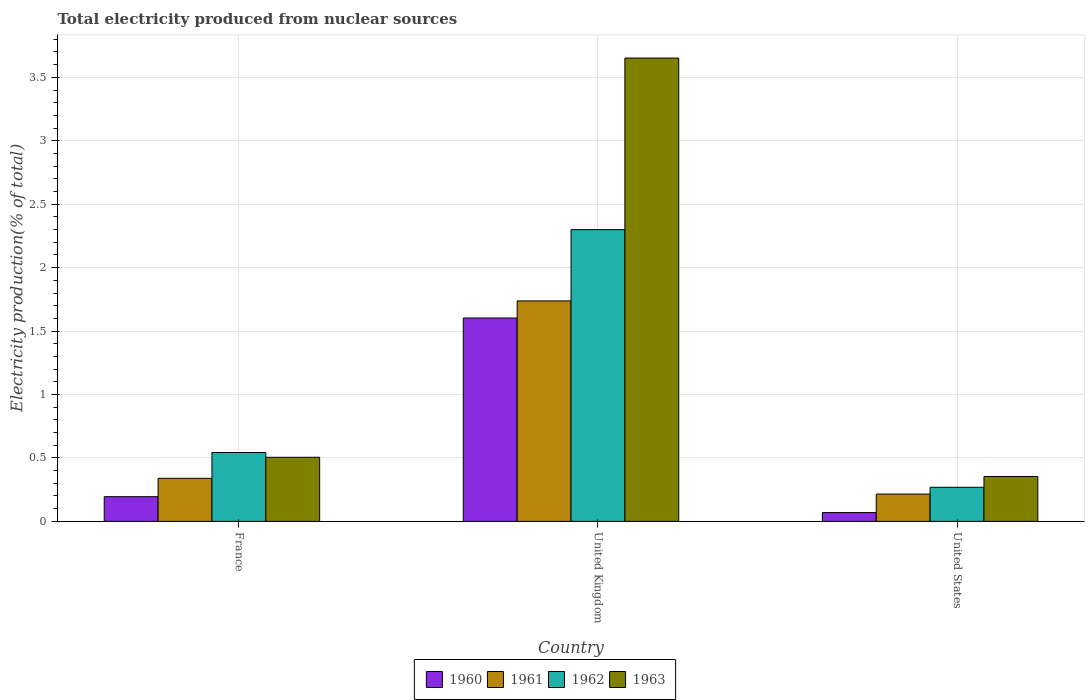Are the number of bars per tick equal to the number of legend labels?
Ensure brevity in your answer.  Yes. Are the number of bars on each tick of the X-axis equal?
Your answer should be very brief. Yes. How many bars are there on the 3rd tick from the left?
Your answer should be very brief. 4. What is the label of the 2nd group of bars from the left?
Ensure brevity in your answer.  United Kingdom. What is the total electricity produced in 1962 in United Kingdom?
Provide a succinct answer. 2.3. Across all countries, what is the maximum total electricity produced in 1962?
Offer a very short reply. 2.3. Across all countries, what is the minimum total electricity produced in 1963?
Give a very brief answer. 0.35. In which country was the total electricity produced in 1963 minimum?
Offer a very short reply. United States. What is the total total electricity produced in 1960 in the graph?
Ensure brevity in your answer.  1.87. What is the difference between the total electricity produced in 1961 in France and that in United States?
Keep it short and to the point. 0.12. What is the difference between the total electricity produced in 1962 in France and the total electricity produced in 1961 in United States?
Keep it short and to the point. 0.33. What is the average total electricity produced in 1962 per country?
Your answer should be very brief. 1.04. What is the difference between the total electricity produced of/in 1961 and total electricity produced of/in 1962 in United Kingdom?
Provide a succinct answer. -0.56. In how many countries, is the total electricity produced in 1960 greater than 3.7 %?
Provide a succinct answer. 0. What is the ratio of the total electricity produced in 1962 in France to that in United States?
Provide a succinct answer. 2.02. Is the total electricity produced in 1962 in France less than that in United States?
Your response must be concise. No. What is the difference between the highest and the second highest total electricity produced in 1963?
Make the answer very short. -3.15. What is the difference between the highest and the lowest total electricity produced in 1962?
Provide a short and direct response. 2.03. In how many countries, is the total electricity produced in 1963 greater than the average total electricity produced in 1963 taken over all countries?
Provide a short and direct response. 1. Is the sum of the total electricity produced in 1962 in United Kingdom and United States greater than the maximum total electricity produced in 1960 across all countries?
Give a very brief answer. Yes. What does the 4th bar from the left in France represents?
Keep it short and to the point. 1963. Is it the case that in every country, the sum of the total electricity produced in 1961 and total electricity produced in 1962 is greater than the total electricity produced in 1960?
Your response must be concise. Yes. How many bars are there?
Ensure brevity in your answer.  12. How many countries are there in the graph?
Provide a short and direct response. 3. What is the difference between two consecutive major ticks on the Y-axis?
Offer a terse response. 0.5. Are the values on the major ticks of Y-axis written in scientific E-notation?
Ensure brevity in your answer.  No. Does the graph contain any zero values?
Provide a succinct answer. No. What is the title of the graph?
Provide a succinct answer. Total electricity produced from nuclear sources. Does "1985" appear as one of the legend labels in the graph?
Provide a succinct answer. No. What is the label or title of the Y-axis?
Make the answer very short. Electricity production(% of total). What is the Electricity production(% of total) in 1960 in France?
Offer a very short reply. 0.19. What is the Electricity production(% of total) of 1961 in France?
Your answer should be very brief. 0.34. What is the Electricity production(% of total) in 1962 in France?
Provide a short and direct response. 0.54. What is the Electricity production(% of total) of 1963 in France?
Ensure brevity in your answer.  0.51. What is the Electricity production(% of total) in 1960 in United Kingdom?
Provide a succinct answer. 1.6. What is the Electricity production(% of total) of 1961 in United Kingdom?
Keep it short and to the point. 1.74. What is the Electricity production(% of total) in 1962 in United Kingdom?
Make the answer very short. 2.3. What is the Electricity production(% of total) of 1963 in United Kingdom?
Offer a very short reply. 3.65. What is the Electricity production(% of total) of 1960 in United States?
Your answer should be compact. 0.07. What is the Electricity production(% of total) of 1961 in United States?
Your answer should be very brief. 0.22. What is the Electricity production(% of total) of 1962 in United States?
Provide a short and direct response. 0.27. What is the Electricity production(% of total) in 1963 in United States?
Your answer should be compact. 0.35. Across all countries, what is the maximum Electricity production(% of total) in 1960?
Make the answer very short. 1.6. Across all countries, what is the maximum Electricity production(% of total) in 1961?
Offer a very short reply. 1.74. Across all countries, what is the maximum Electricity production(% of total) in 1962?
Keep it short and to the point. 2.3. Across all countries, what is the maximum Electricity production(% of total) of 1963?
Your response must be concise. 3.65. Across all countries, what is the minimum Electricity production(% of total) in 1960?
Your answer should be compact. 0.07. Across all countries, what is the minimum Electricity production(% of total) of 1961?
Keep it short and to the point. 0.22. Across all countries, what is the minimum Electricity production(% of total) in 1962?
Offer a very short reply. 0.27. Across all countries, what is the minimum Electricity production(% of total) in 1963?
Give a very brief answer. 0.35. What is the total Electricity production(% of total) of 1960 in the graph?
Give a very brief answer. 1.87. What is the total Electricity production(% of total) in 1961 in the graph?
Offer a very short reply. 2.29. What is the total Electricity production(% of total) of 1962 in the graph?
Make the answer very short. 3.11. What is the total Electricity production(% of total) in 1963 in the graph?
Make the answer very short. 4.51. What is the difference between the Electricity production(% of total) of 1960 in France and that in United Kingdom?
Make the answer very short. -1.41. What is the difference between the Electricity production(% of total) of 1961 in France and that in United Kingdom?
Offer a terse response. -1.4. What is the difference between the Electricity production(% of total) of 1962 in France and that in United Kingdom?
Make the answer very short. -1.76. What is the difference between the Electricity production(% of total) of 1963 in France and that in United Kingdom?
Offer a terse response. -3.15. What is the difference between the Electricity production(% of total) of 1960 in France and that in United States?
Offer a very short reply. 0.13. What is the difference between the Electricity production(% of total) of 1961 in France and that in United States?
Give a very brief answer. 0.12. What is the difference between the Electricity production(% of total) of 1962 in France and that in United States?
Provide a short and direct response. 0.27. What is the difference between the Electricity production(% of total) of 1963 in France and that in United States?
Your answer should be compact. 0.15. What is the difference between the Electricity production(% of total) of 1960 in United Kingdom and that in United States?
Provide a short and direct response. 1.53. What is the difference between the Electricity production(% of total) of 1961 in United Kingdom and that in United States?
Provide a short and direct response. 1.52. What is the difference between the Electricity production(% of total) of 1962 in United Kingdom and that in United States?
Your response must be concise. 2.03. What is the difference between the Electricity production(% of total) of 1963 in United Kingdom and that in United States?
Your response must be concise. 3.3. What is the difference between the Electricity production(% of total) in 1960 in France and the Electricity production(% of total) in 1961 in United Kingdom?
Your answer should be very brief. -1.54. What is the difference between the Electricity production(% of total) of 1960 in France and the Electricity production(% of total) of 1962 in United Kingdom?
Your answer should be compact. -2.11. What is the difference between the Electricity production(% of total) in 1960 in France and the Electricity production(% of total) in 1963 in United Kingdom?
Your answer should be compact. -3.46. What is the difference between the Electricity production(% of total) of 1961 in France and the Electricity production(% of total) of 1962 in United Kingdom?
Your answer should be compact. -1.96. What is the difference between the Electricity production(% of total) of 1961 in France and the Electricity production(% of total) of 1963 in United Kingdom?
Provide a succinct answer. -3.31. What is the difference between the Electricity production(% of total) in 1962 in France and the Electricity production(% of total) in 1963 in United Kingdom?
Give a very brief answer. -3.11. What is the difference between the Electricity production(% of total) of 1960 in France and the Electricity production(% of total) of 1961 in United States?
Give a very brief answer. -0.02. What is the difference between the Electricity production(% of total) of 1960 in France and the Electricity production(% of total) of 1962 in United States?
Keep it short and to the point. -0.07. What is the difference between the Electricity production(% of total) of 1960 in France and the Electricity production(% of total) of 1963 in United States?
Provide a succinct answer. -0.16. What is the difference between the Electricity production(% of total) in 1961 in France and the Electricity production(% of total) in 1962 in United States?
Offer a terse response. 0.07. What is the difference between the Electricity production(% of total) in 1961 in France and the Electricity production(% of total) in 1963 in United States?
Keep it short and to the point. -0.01. What is the difference between the Electricity production(% of total) in 1962 in France and the Electricity production(% of total) in 1963 in United States?
Provide a succinct answer. 0.19. What is the difference between the Electricity production(% of total) in 1960 in United Kingdom and the Electricity production(% of total) in 1961 in United States?
Provide a short and direct response. 1.39. What is the difference between the Electricity production(% of total) in 1960 in United Kingdom and the Electricity production(% of total) in 1962 in United States?
Your answer should be compact. 1.33. What is the difference between the Electricity production(% of total) in 1960 in United Kingdom and the Electricity production(% of total) in 1963 in United States?
Your answer should be very brief. 1.25. What is the difference between the Electricity production(% of total) of 1961 in United Kingdom and the Electricity production(% of total) of 1962 in United States?
Provide a short and direct response. 1.47. What is the difference between the Electricity production(% of total) of 1961 in United Kingdom and the Electricity production(% of total) of 1963 in United States?
Keep it short and to the point. 1.38. What is the difference between the Electricity production(% of total) of 1962 in United Kingdom and the Electricity production(% of total) of 1963 in United States?
Keep it short and to the point. 1.95. What is the average Electricity production(% of total) of 1960 per country?
Ensure brevity in your answer.  0.62. What is the average Electricity production(% of total) in 1961 per country?
Ensure brevity in your answer.  0.76. What is the average Electricity production(% of total) in 1963 per country?
Your answer should be very brief. 1.5. What is the difference between the Electricity production(% of total) in 1960 and Electricity production(% of total) in 1961 in France?
Provide a succinct answer. -0.14. What is the difference between the Electricity production(% of total) of 1960 and Electricity production(% of total) of 1962 in France?
Offer a terse response. -0.35. What is the difference between the Electricity production(% of total) in 1960 and Electricity production(% of total) in 1963 in France?
Provide a short and direct response. -0.31. What is the difference between the Electricity production(% of total) of 1961 and Electricity production(% of total) of 1962 in France?
Ensure brevity in your answer.  -0.2. What is the difference between the Electricity production(% of total) in 1961 and Electricity production(% of total) in 1963 in France?
Provide a short and direct response. -0.17. What is the difference between the Electricity production(% of total) of 1962 and Electricity production(% of total) of 1963 in France?
Your answer should be very brief. 0.04. What is the difference between the Electricity production(% of total) of 1960 and Electricity production(% of total) of 1961 in United Kingdom?
Offer a terse response. -0.13. What is the difference between the Electricity production(% of total) in 1960 and Electricity production(% of total) in 1962 in United Kingdom?
Make the answer very short. -0.7. What is the difference between the Electricity production(% of total) in 1960 and Electricity production(% of total) in 1963 in United Kingdom?
Make the answer very short. -2.05. What is the difference between the Electricity production(% of total) in 1961 and Electricity production(% of total) in 1962 in United Kingdom?
Provide a short and direct response. -0.56. What is the difference between the Electricity production(% of total) of 1961 and Electricity production(% of total) of 1963 in United Kingdom?
Your answer should be compact. -1.91. What is the difference between the Electricity production(% of total) in 1962 and Electricity production(% of total) in 1963 in United Kingdom?
Offer a terse response. -1.35. What is the difference between the Electricity production(% of total) of 1960 and Electricity production(% of total) of 1961 in United States?
Keep it short and to the point. -0.15. What is the difference between the Electricity production(% of total) in 1960 and Electricity production(% of total) in 1962 in United States?
Give a very brief answer. -0.2. What is the difference between the Electricity production(% of total) in 1960 and Electricity production(% of total) in 1963 in United States?
Ensure brevity in your answer.  -0.28. What is the difference between the Electricity production(% of total) of 1961 and Electricity production(% of total) of 1962 in United States?
Provide a succinct answer. -0.05. What is the difference between the Electricity production(% of total) of 1961 and Electricity production(% of total) of 1963 in United States?
Make the answer very short. -0.14. What is the difference between the Electricity production(% of total) in 1962 and Electricity production(% of total) in 1963 in United States?
Provide a short and direct response. -0.09. What is the ratio of the Electricity production(% of total) of 1960 in France to that in United Kingdom?
Your answer should be very brief. 0.12. What is the ratio of the Electricity production(% of total) in 1961 in France to that in United Kingdom?
Your response must be concise. 0.2. What is the ratio of the Electricity production(% of total) in 1962 in France to that in United Kingdom?
Provide a succinct answer. 0.24. What is the ratio of the Electricity production(% of total) of 1963 in France to that in United Kingdom?
Give a very brief answer. 0.14. What is the ratio of the Electricity production(% of total) of 1960 in France to that in United States?
Offer a very short reply. 2.81. What is the ratio of the Electricity production(% of total) of 1961 in France to that in United States?
Offer a very short reply. 1.58. What is the ratio of the Electricity production(% of total) in 1962 in France to that in United States?
Ensure brevity in your answer.  2.02. What is the ratio of the Electricity production(% of total) in 1963 in France to that in United States?
Ensure brevity in your answer.  1.43. What is the ratio of the Electricity production(% of total) of 1960 in United Kingdom to that in United States?
Your answer should be very brief. 23.14. What is the ratio of the Electricity production(% of total) of 1961 in United Kingdom to that in United States?
Offer a terse response. 8.08. What is the ratio of the Electricity production(% of total) of 1962 in United Kingdom to that in United States?
Offer a very short reply. 8.56. What is the ratio of the Electricity production(% of total) in 1963 in United Kingdom to that in United States?
Your answer should be compact. 10.32. What is the difference between the highest and the second highest Electricity production(% of total) in 1960?
Provide a succinct answer. 1.41. What is the difference between the highest and the second highest Electricity production(% of total) in 1961?
Provide a succinct answer. 1.4. What is the difference between the highest and the second highest Electricity production(% of total) in 1962?
Provide a succinct answer. 1.76. What is the difference between the highest and the second highest Electricity production(% of total) of 1963?
Keep it short and to the point. 3.15. What is the difference between the highest and the lowest Electricity production(% of total) of 1960?
Offer a terse response. 1.53. What is the difference between the highest and the lowest Electricity production(% of total) in 1961?
Your answer should be compact. 1.52. What is the difference between the highest and the lowest Electricity production(% of total) in 1962?
Your answer should be very brief. 2.03. What is the difference between the highest and the lowest Electricity production(% of total) of 1963?
Keep it short and to the point. 3.3. 